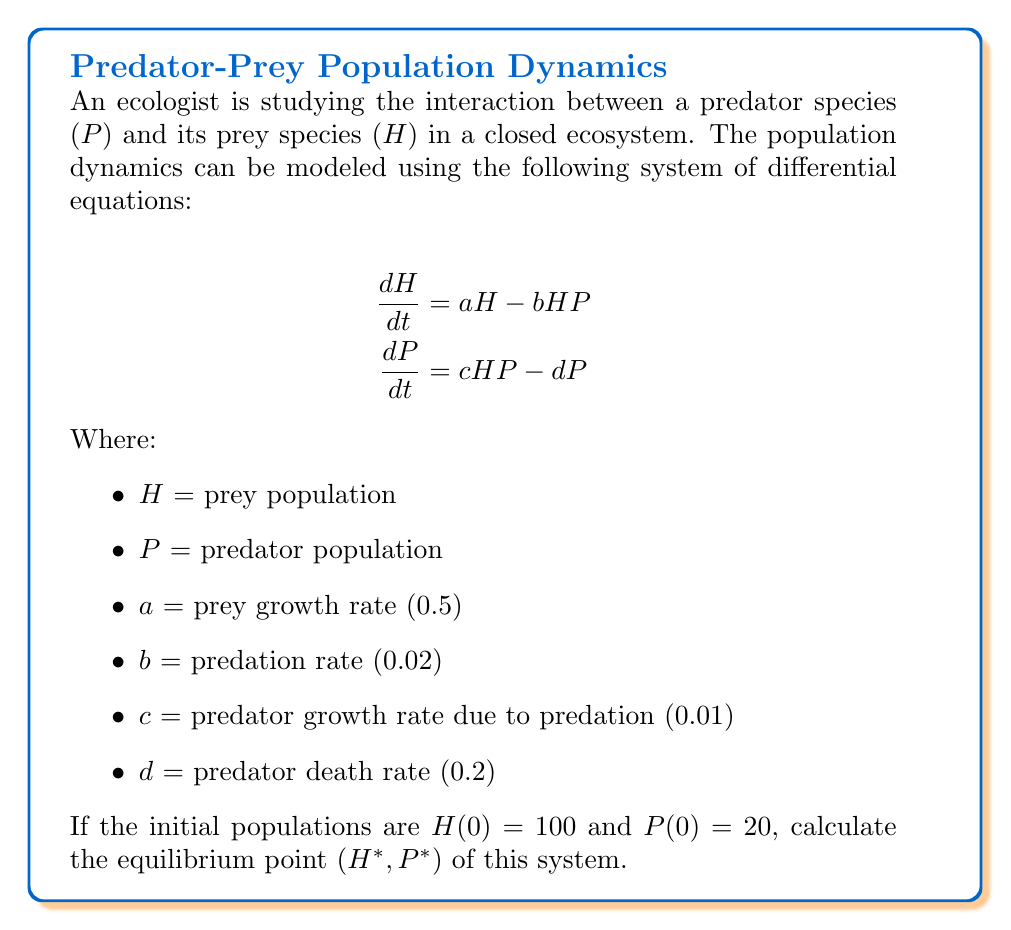Provide a solution to this math problem. To find the equilibrium point, we need to set both differential equations to zero and solve for H and P:

1) Set $\frac{dH}{dt} = 0$ and $\frac{dP}{dt} = 0$:

   $$0 = aH - bHP$$
   $$0 = cHP - dP$$

2) From the second equation:
   $$cHP - dP = 0$$
   $$P(cH - d) = 0$$

   This is satisfied when $P = 0$ or when $cH - d = 0$

3) If $P = 0$, then from the first equation:
   $$aH = 0$$
   Which gives $H = 0$. However, (0,0) is not a valid equilibrium for this ecosystem.

4) So, we solve $cH - d = 0$:
   $$cH = d$$
   $$H = \frac{d}{c} = \frac{0.2}{0.01} = 20$$

5) Substitute this value of H into the first equation:
   $$0 = aH - bHP$$
   $$0 = 0.5(20) - 0.02(20)P$$
   $$10 = 0.4P$$
   $$P = 25$$

Therefore, the equilibrium point (H*, P*) is (20, 25).
Answer: (20, 25) 